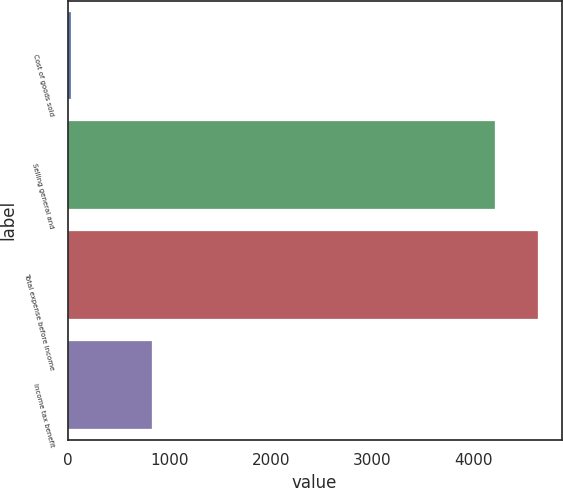Convert chart to OTSL. <chart><loc_0><loc_0><loc_500><loc_500><bar_chart><fcel>Cost of goods sold<fcel>Selling general and<fcel>Total expense before income<fcel>Income tax benefit<nl><fcel>28<fcel>4213<fcel>4634.3<fcel>827<nl></chart> 